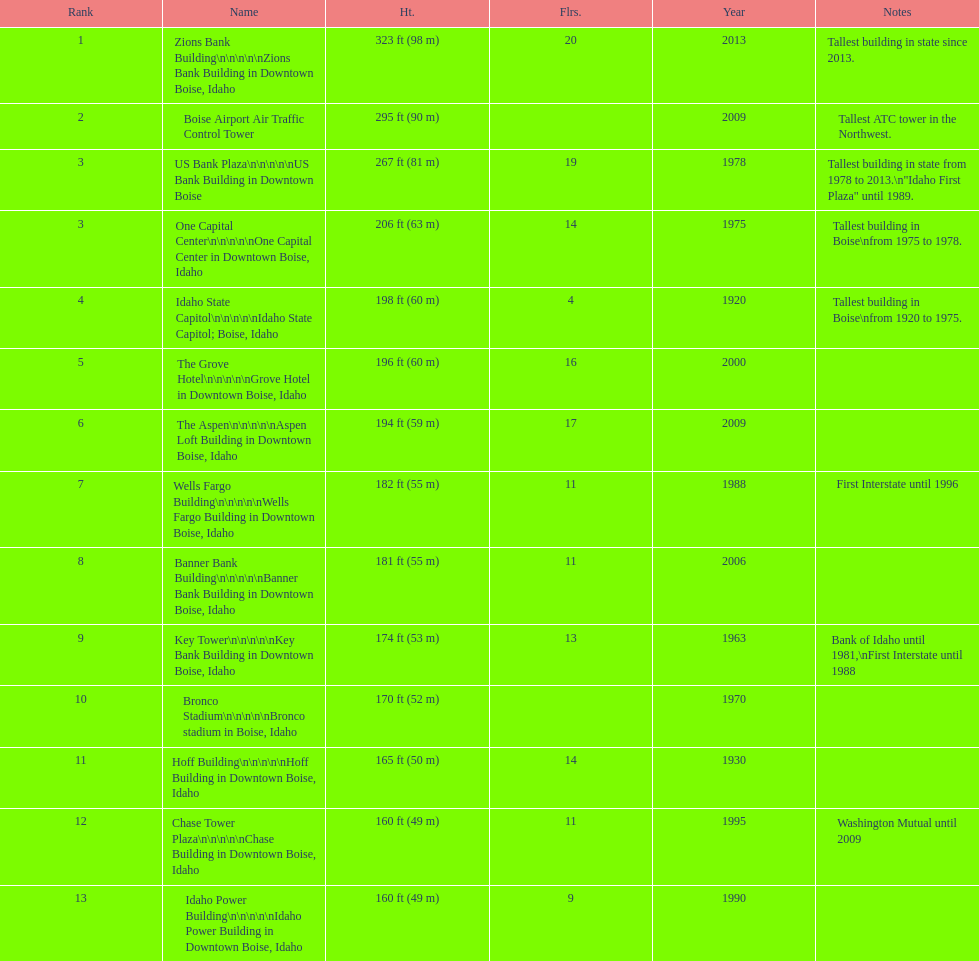How many floors does the tallest building have? 20. 